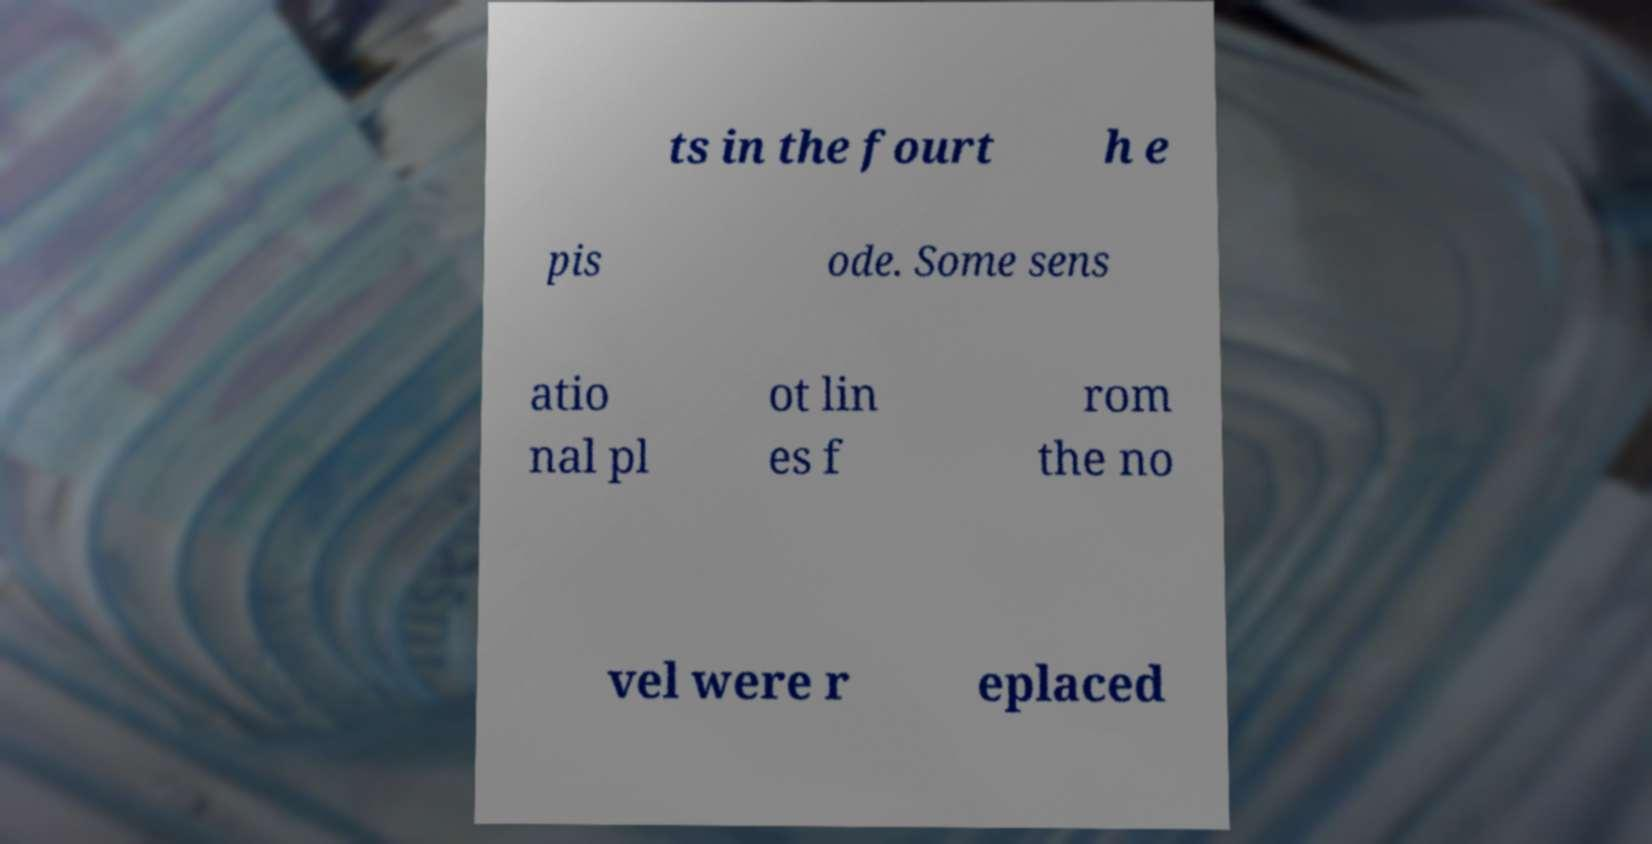There's text embedded in this image that I need extracted. Can you transcribe it verbatim? ts in the fourt h e pis ode. Some sens atio nal pl ot lin es f rom the no vel were r eplaced 